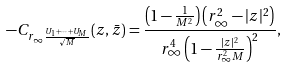Convert formula to latex. <formula><loc_0><loc_0><loc_500><loc_500>- C _ { r _ { \infty } \frac { U _ { 1 } + \dots + U _ { M } } { \sqrt { M } } } ( z , \bar { z } ) = \frac { \left ( 1 - \frac { 1 } { M ^ { 2 } } \right ) \left ( r _ { \infty } ^ { 2 } - | z | ^ { 2 } \right ) } { r _ { \infty } ^ { 4 } \left ( 1 - \frac { | z | ^ { 2 } } { r _ { \infty } ^ { 2 } M } \right ) ^ { 2 } } ,</formula> 